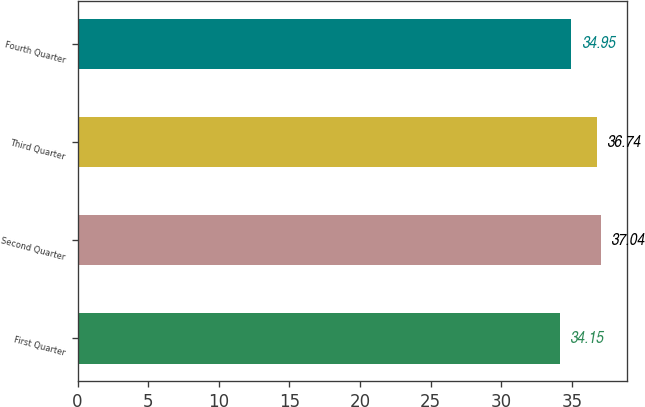Convert chart to OTSL. <chart><loc_0><loc_0><loc_500><loc_500><bar_chart><fcel>First Quarter<fcel>Second Quarter<fcel>Third Quarter<fcel>Fourth Quarter<nl><fcel>34.15<fcel>37.04<fcel>36.74<fcel>34.95<nl></chart> 